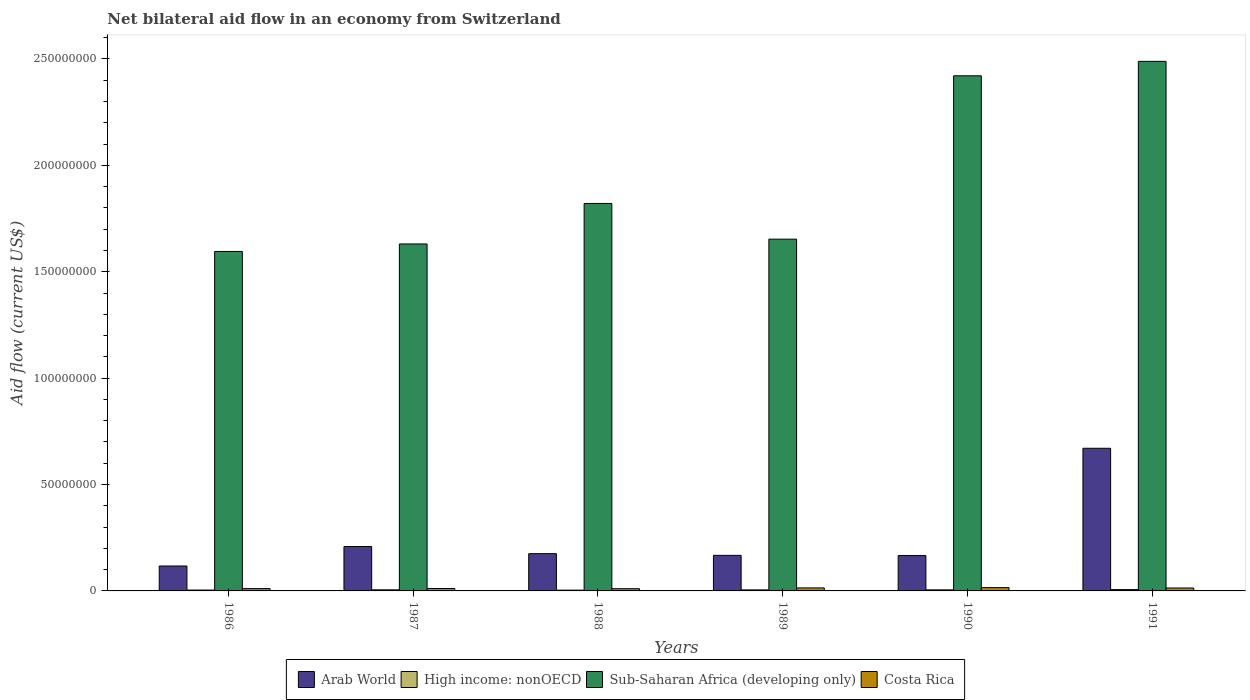How many different coloured bars are there?
Your answer should be compact. 4. How many groups of bars are there?
Make the answer very short. 6. How many bars are there on the 5th tick from the left?
Give a very brief answer. 4. What is the net bilateral aid flow in Arab World in 1988?
Offer a terse response. 1.75e+07. Across all years, what is the maximum net bilateral aid flow in Costa Rica?
Provide a succinct answer. 1.55e+06. In which year was the net bilateral aid flow in High income: nonOECD minimum?
Your response must be concise. 1988. What is the total net bilateral aid flow in Costa Rica in the graph?
Provide a short and direct response. 7.62e+06. What is the difference between the net bilateral aid flow in High income: nonOECD in 1986 and the net bilateral aid flow in Sub-Saharan Africa (developing only) in 1989?
Keep it short and to the point. -1.65e+08. What is the average net bilateral aid flow in High income: nonOECD per year?
Your response must be concise. 4.83e+05. In the year 1986, what is the difference between the net bilateral aid flow in Arab World and net bilateral aid flow in High income: nonOECD?
Ensure brevity in your answer.  1.13e+07. In how many years, is the net bilateral aid flow in Arab World greater than 10000000 US$?
Ensure brevity in your answer.  6. What is the ratio of the net bilateral aid flow in Sub-Saharan Africa (developing only) in 1987 to that in 1989?
Your response must be concise. 0.99. Is the difference between the net bilateral aid flow in Arab World in 1988 and 1989 greater than the difference between the net bilateral aid flow in High income: nonOECD in 1988 and 1989?
Offer a terse response. Yes. What is the difference between the highest and the second highest net bilateral aid flow in Sub-Saharan Africa (developing only)?
Your answer should be compact. 6.79e+06. What is the difference between the highest and the lowest net bilateral aid flow in Arab World?
Keep it short and to the point. 5.53e+07. In how many years, is the net bilateral aid flow in High income: nonOECD greater than the average net bilateral aid flow in High income: nonOECD taken over all years?
Provide a succinct answer. 3. What does the 1st bar from the left in 1988 represents?
Make the answer very short. Arab World. What does the 4th bar from the right in 1986 represents?
Provide a succinct answer. Arab World. Is it the case that in every year, the sum of the net bilateral aid flow in Sub-Saharan Africa (developing only) and net bilateral aid flow in Arab World is greater than the net bilateral aid flow in Costa Rica?
Your answer should be compact. Yes. How many years are there in the graph?
Provide a short and direct response. 6. Where does the legend appear in the graph?
Provide a succinct answer. Bottom center. How many legend labels are there?
Make the answer very short. 4. What is the title of the graph?
Keep it short and to the point. Net bilateral aid flow in an economy from Switzerland. Does "United Arab Emirates" appear as one of the legend labels in the graph?
Your response must be concise. No. What is the label or title of the Y-axis?
Keep it short and to the point. Aid flow (current US$). What is the Aid flow (current US$) in Arab World in 1986?
Give a very brief answer. 1.17e+07. What is the Aid flow (current US$) in Sub-Saharan Africa (developing only) in 1986?
Your answer should be very brief. 1.60e+08. What is the Aid flow (current US$) in Costa Rica in 1986?
Your answer should be compact. 1.10e+06. What is the Aid flow (current US$) in Arab World in 1987?
Offer a very short reply. 2.09e+07. What is the Aid flow (current US$) in High income: nonOECD in 1987?
Provide a succinct answer. 5.20e+05. What is the Aid flow (current US$) of Sub-Saharan Africa (developing only) in 1987?
Make the answer very short. 1.63e+08. What is the Aid flow (current US$) of Costa Rica in 1987?
Your response must be concise. 1.14e+06. What is the Aid flow (current US$) in Arab World in 1988?
Make the answer very short. 1.75e+07. What is the Aid flow (current US$) of High income: nonOECD in 1988?
Your response must be concise. 3.60e+05. What is the Aid flow (current US$) of Sub-Saharan Africa (developing only) in 1988?
Offer a terse response. 1.82e+08. What is the Aid flow (current US$) of Costa Rica in 1988?
Your response must be concise. 1.04e+06. What is the Aid flow (current US$) of Arab World in 1989?
Your answer should be compact. 1.67e+07. What is the Aid flow (current US$) of Sub-Saharan Africa (developing only) in 1989?
Offer a very short reply. 1.65e+08. What is the Aid flow (current US$) of Costa Rica in 1989?
Your answer should be very brief. 1.41e+06. What is the Aid flow (current US$) of Arab World in 1990?
Your answer should be very brief. 1.66e+07. What is the Aid flow (current US$) in Sub-Saharan Africa (developing only) in 1990?
Provide a succinct answer. 2.42e+08. What is the Aid flow (current US$) of Costa Rica in 1990?
Ensure brevity in your answer.  1.55e+06. What is the Aid flow (current US$) of Arab World in 1991?
Keep it short and to the point. 6.70e+07. What is the Aid flow (current US$) in High income: nonOECD in 1991?
Give a very brief answer. 6.30e+05. What is the Aid flow (current US$) in Sub-Saharan Africa (developing only) in 1991?
Give a very brief answer. 2.49e+08. What is the Aid flow (current US$) in Costa Rica in 1991?
Offer a very short reply. 1.38e+06. Across all years, what is the maximum Aid flow (current US$) of Arab World?
Your answer should be very brief. 6.70e+07. Across all years, what is the maximum Aid flow (current US$) of High income: nonOECD?
Your answer should be very brief. 6.30e+05. Across all years, what is the maximum Aid flow (current US$) of Sub-Saharan Africa (developing only)?
Give a very brief answer. 2.49e+08. Across all years, what is the maximum Aid flow (current US$) in Costa Rica?
Ensure brevity in your answer.  1.55e+06. Across all years, what is the minimum Aid flow (current US$) in Arab World?
Provide a short and direct response. 1.17e+07. Across all years, what is the minimum Aid flow (current US$) in High income: nonOECD?
Your answer should be very brief. 3.60e+05. Across all years, what is the minimum Aid flow (current US$) of Sub-Saharan Africa (developing only)?
Give a very brief answer. 1.60e+08. Across all years, what is the minimum Aid flow (current US$) in Costa Rica?
Ensure brevity in your answer.  1.04e+06. What is the total Aid flow (current US$) in Arab World in the graph?
Offer a terse response. 1.50e+08. What is the total Aid flow (current US$) in High income: nonOECD in the graph?
Your answer should be compact. 2.90e+06. What is the total Aid flow (current US$) of Sub-Saharan Africa (developing only) in the graph?
Your response must be concise. 1.16e+09. What is the total Aid flow (current US$) in Costa Rica in the graph?
Your answer should be very brief. 7.62e+06. What is the difference between the Aid flow (current US$) in Arab World in 1986 and that in 1987?
Your answer should be very brief. -9.15e+06. What is the difference between the Aid flow (current US$) of Sub-Saharan Africa (developing only) in 1986 and that in 1987?
Ensure brevity in your answer.  -3.52e+06. What is the difference between the Aid flow (current US$) in Costa Rica in 1986 and that in 1987?
Offer a very short reply. -4.00e+04. What is the difference between the Aid flow (current US$) of Arab World in 1986 and that in 1988?
Your response must be concise. -5.80e+06. What is the difference between the Aid flow (current US$) in Sub-Saharan Africa (developing only) in 1986 and that in 1988?
Your answer should be compact. -2.26e+07. What is the difference between the Aid flow (current US$) in Costa Rica in 1986 and that in 1988?
Keep it short and to the point. 6.00e+04. What is the difference between the Aid flow (current US$) of Arab World in 1986 and that in 1989?
Ensure brevity in your answer.  -4.99e+06. What is the difference between the Aid flow (current US$) of High income: nonOECD in 1986 and that in 1989?
Provide a succinct answer. -7.00e+04. What is the difference between the Aid flow (current US$) in Sub-Saharan Africa (developing only) in 1986 and that in 1989?
Offer a terse response. -5.78e+06. What is the difference between the Aid flow (current US$) of Costa Rica in 1986 and that in 1989?
Give a very brief answer. -3.10e+05. What is the difference between the Aid flow (current US$) in Arab World in 1986 and that in 1990?
Provide a succinct answer. -4.90e+06. What is the difference between the Aid flow (current US$) in Sub-Saharan Africa (developing only) in 1986 and that in 1990?
Keep it short and to the point. -8.26e+07. What is the difference between the Aid flow (current US$) in Costa Rica in 1986 and that in 1990?
Your answer should be very brief. -4.50e+05. What is the difference between the Aid flow (current US$) in Arab World in 1986 and that in 1991?
Ensure brevity in your answer.  -5.53e+07. What is the difference between the Aid flow (current US$) of Sub-Saharan Africa (developing only) in 1986 and that in 1991?
Give a very brief answer. -8.93e+07. What is the difference between the Aid flow (current US$) of Costa Rica in 1986 and that in 1991?
Make the answer very short. -2.80e+05. What is the difference between the Aid flow (current US$) of Arab World in 1987 and that in 1988?
Give a very brief answer. 3.35e+06. What is the difference between the Aid flow (current US$) of Sub-Saharan Africa (developing only) in 1987 and that in 1988?
Offer a very short reply. -1.90e+07. What is the difference between the Aid flow (current US$) in Arab World in 1987 and that in 1989?
Make the answer very short. 4.16e+06. What is the difference between the Aid flow (current US$) of Sub-Saharan Africa (developing only) in 1987 and that in 1989?
Your answer should be compact. -2.26e+06. What is the difference between the Aid flow (current US$) of Arab World in 1987 and that in 1990?
Your answer should be very brief. 4.25e+06. What is the difference between the Aid flow (current US$) in High income: nonOECD in 1987 and that in 1990?
Your answer should be very brief. 2.00e+04. What is the difference between the Aid flow (current US$) in Sub-Saharan Africa (developing only) in 1987 and that in 1990?
Your answer should be very brief. -7.90e+07. What is the difference between the Aid flow (current US$) in Costa Rica in 1987 and that in 1990?
Make the answer very short. -4.10e+05. What is the difference between the Aid flow (current US$) of Arab World in 1987 and that in 1991?
Provide a short and direct response. -4.62e+07. What is the difference between the Aid flow (current US$) in Sub-Saharan Africa (developing only) in 1987 and that in 1991?
Offer a very short reply. -8.58e+07. What is the difference between the Aid flow (current US$) of Arab World in 1988 and that in 1989?
Give a very brief answer. 8.10e+05. What is the difference between the Aid flow (current US$) in Sub-Saharan Africa (developing only) in 1988 and that in 1989?
Your answer should be compact. 1.68e+07. What is the difference between the Aid flow (current US$) in Costa Rica in 1988 and that in 1989?
Offer a terse response. -3.70e+05. What is the difference between the Aid flow (current US$) in Arab World in 1988 and that in 1990?
Your answer should be very brief. 9.00e+05. What is the difference between the Aid flow (current US$) of Sub-Saharan Africa (developing only) in 1988 and that in 1990?
Give a very brief answer. -6.00e+07. What is the difference between the Aid flow (current US$) of Costa Rica in 1988 and that in 1990?
Keep it short and to the point. -5.10e+05. What is the difference between the Aid flow (current US$) in Arab World in 1988 and that in 1991?
Make the answer very short. -4.95e+07. What is the difference between the Aid flow (current US$) in Sub-Saharan Africa (developing only) in 1988 and that in 1991?
Ensure brevity in your answer.  -6.68e+07. What is the difference between the Aid flow (current US$) of High income: nonOECD in 1989 and that in 1990?
Your response must be concise. -2.00e+04. What is the difference between the Aid flow (current US$) in Sub-Saharan Africa (developing only) in 1989 and that in 1990?
Offer a very short reply. -7.68e+07. What is the difference between the Aid flow (current US$) in Costa Rica in 1989 and that in 1990?
Make the answer very short. -1.40e+05. What is the difference between the Aid flow (current US$) in Arab World in 1989 and that in 1991?
Provide a short and direct response. -5.03e+07. What is the difference between the Aid flow (current US$) of Sub-Saharan Africa (developing only) in 1989 and that in 1991?
Your answer should be compact. -8.36e+07. What is the difference between the Aid flow (current US$) of Costa Rica in 1989 and that in 1991?
Give a very brief answer. 3.00e+04. What is the difference between the Aid flow (current US$) in Arab World in 1990 and that in 1991?
Ensure brevity in your answer.  -5.04e+07. What is the difference between the Aid flow (current US$) of Sub-Saharan Africa (developing only) in 1990 and that in 1991?
Give a very brief answer. -6.79e+06. What is the difference between the Aid flow (current US$) of Costa Rica in 1990 and that in 1991?
Your answer should be compact. 1.70e+05. What is the difference between the Aid flow (current US$) in Arab World in 1986 and the Aid flow (current US$) in High income: nonOECD in 1987?
Offer a terse response. 1.12e+07. What is the difference between the Aid flow (current US$) of Arab World in 1986 and the Aid flow (current US$) of Sub-Saharan Africa (developing only) in 1987?
Offer a terse response. -1.51e+08. What is the difference between the Aid flow (current US$) in Arab World in 1986 and the Aid flow (current US$) in Costa Rica in 1987?
Your answer should be very brief. 1.06e+07. What is the difference between the Aid flow (current US$) in High income: nonOECD in 1986 and the Aid flow (current US$) in Sub-Saharan Africa (developing only) in 1987?
Give a very brief answer. -1.63e+08. What is the difference between the Aid flow (current US$) in High income: nonOECD in 1986 and the Aid flow (current US$) in Costa Rica in 1987?
Offer a terse response. -7.30e+05. What is the difference between the Aid flow (current US$) in Sub-Saharan Africa (developing only) in 1986 and the Aid flow (current US$) in Costa Rica in 1987?
Provide a succinct answer. 1.58e+08. What is the difference between the Aid flow (current US$) in Arab World in 1986 and the Aid flow (current US$) in High income: nonOECD in 1988?
Offer a very short reply. 1.14e+07. What is the difference between the Aid flow (current US$) in Arab World in 1986 and the Aid flow (current US$) in Sub-Saharan Africa (developing only) in 1988?
Offer a terse response. -1.70e+08. What is the difference between the Aid flow (current US$) in Arab World in 1986 and the Aid flow (current US$) in Costa Rica in 1988?
Offer a terse response. 1.07e+07. What is the difference between the Aid flow (current US$) in High income: nonOECD in 1986 and the Aid flow (current US$) in Sub-Saharan Africa (developing only) in 1988?
Your answer should be compact. -1.82e+08. What is the difference between the Aid flow (current US$) of High income: nonOECD in 1986 and the Aid flow (current US$) of Costa Rica in 1988?
Keep it short and to the point. -6.30e+05. What is the difference between the Aid flow (current US$) in Sub-Saharan Africa (developing only) in 1986 and the Aid flow (current US$) in Costa Rica in 1988?
Ensure brevity in your answer.  1.59e+08. What is the difference between the Aid flow (current US$) in Arab World in 1986 and the Aid flow (current US$) in High income: nonOECD in 1989?
Ensure brevity in your answer.  1.12e+07. What is the difference between the Aid flow (current US$) in Arab World in 1986 and the Aid flow (current US$) in Sub-Saharan Africa (developing only) in 1989?
Your answer should be compact. -1.54e+08. What is the difference between the Aid flow (current US$) in Arab World in 1986 and the Aid flow (current US$) in Costa Rica in 1989?
Provide a short and direct response. 1.03e+07. What is the difference between the Aid flow (current US$) of High income: nonOECD in 1986 and the Aid flow (current US$) of Sub-Saharan Africa (developing only) in 1989?
Offer a terse response. -1.65e+08. What is the difference between the Aid flow (current US$) of Sub-Saharan Africa (developing only) in 1986 and the Aid flow (current US$) of Costa Rica in 1989?
Your response must be concise. 1.58e+08. What is the difference between the Aid flow (current US$) of Arab World in 1986 and the Aid flow (current US$) of High income: nonOECD in 1990?
Your answer should be compact. 1.12e+07. What is the difference between the Aid flow (current US$) in Arab World in 1986 and the Aid flow (current US$) in Sub-Saharan Africa (developing only) in 1990?
Your response must be concise. -2.30e+08. What is the difference between the Aid flow (current US$) of Arab World in 1986 and the Aid flow (current US$) of Costa Rica in 1990?
Keep it short and to the point. 1.02e+07. What is the difference between the Aid flow (current US$) in High income: nonOECD in 1986 and the Aid flow (current US$) in Sub-Saharan Africa (developing only) in 1990?
Your answer should be compact. -2.42e+08. What is the difference between the Aid flow (current US$) in High income: nonOECD in 1986 and the Aid flow (current US$) in Costa Rica in 1990?
Make the answer very short. -1.14e+06. What is the difference between the Aid flow (current US$) in Sub-Saharan Africa (developing only) in 1986 and the Aid flow (current US$) in Costa Rica in 1990?
Provide a short and direct response. 1.58e+08. What is the difference between the Aid flow (current US$) of Arab World in 1986 and the Aid flow (current US$) of High income: nonOECD in 1991?
Make the answer very short. 1.11e+07. What is the difference between the Aid flow (current US$) of Arab World in 1986 and the Aid flow (current US$) of Sub-Saharan Africa (developing only) in 1991?
Your answer should be compact. -2.37e+08. What is the difference between the Aid flow (current US$) of Arab World in 1986 and the Aid flow (current US$) of Costa Rica in 1991?
Keep it short and to the point. 1.03e+07. What is the difference between the Aid flow (current US$) of High income: nonOECD in 1986 and the Aid flow (current US$) of Sub-Saharan Africa (developing only) in 1991?
Your answer should be compact. -2.48e+08. What is the difference between the Aid flow (current US$) in High income: nonOECD in 1986 and the Aid flow (current US$) in Costa Rica in 1991?
Your answer should be very brief. -9.70e+05. What is the difference between the Aid flow (current US$) of Sub-Saharan Africa (developing only) in 1986 and the Aid flow (current US$) of Costa Rica in 1991?
Offer a terse response. 1.58e+08. What is the difference between the Aid flow (current US$) of Arab World in 1987 and the Aid flow (current US$) of High income: nonOECD in 1988?
Make the answer very short. 2.05e+07. What is the difference between the Aid flow (current US$) of Arab World in 1987 and the Aid flow (current US$) of Sub-Saharan Africa (developing only) in 1988?
Offer a very short reply. -1.61e+08. What is the difference between the Aid flow (current US$) of Arab World in 1987 and the Aid flow (current US$) of Costa Rica in 1988?
Offer a very short reply. 1.98e+07. What is the difference between the Aid flow (current US$) of High income: nonOECD in 1987 and the Aid flow (current US$) of Sub-Saharan Africa (developing only) in 1988?
Your answer should be compact. -1.82e+08. What is the difference between the Aid flow (current US$) of High income: nonOECD in 1987 and the Aid flow (current US$) of Costa Rica in 1988?
Keep it short and to the point. -5.20e+05. What is the difference between the Aid flow (current US$) of Sub-Saharan Africa (developing only) in 1987 and the Aid flow (current US$) of Costa Rica in 1988?
Make the answer very short. 1.62e+08. What is the difference between the Aid flow (current US$) in Arab World in 1987 and the Aid flow (current US$) in High income: nonOECD in 1989?
Provide a succinct answer. 2.04e+07. What is the difference between the Aid flow (current US$) of Arab World in 1987 and the Aid flow (current US$) of Sub-Saharan Africa (developing only) in 1989?
Provide a succinct answer. -1.44e+08. What is the difference between the Aid flow (current US$) of Arab World in 1987 and the Aid flow (current US$) of Costa Rica in 1989?
Offer a very short reply. 1.95e+07. What is the difference between the Aid flow (current US$) in High income: nonOECD in 1987 and the Aid flow (current US$) in Sub-Saharan Africa (developing only) in 1989?
Your answer should be very brief. -1.65e+08. What is the difference between the Aid flow (current US$) of High income: nonOECD in 1987 and the Aid flow (current US$) of Costa Rica in 1989?
Your answer should be very brief. -8.90e+05. What is the difference between the Aid flow (current US$) in Sub-Saharan Africa (developing only) in 1987 and the Aid flow (current US$) in Costa Rica in 1989?
Keep it short and to the point. 1.62e+08. What is the difference between the Aid flow (current US$) in Arab World in 1987 and the Aid flow (current US$) in High income: nonOECD in 1990?
Your answer should be compact. 2.04e+07. What is the difference between the Aid flow (current US$) of Arab World in 1987 and the Aid flow (current US$) of Sub-Saharan Africa (developing only) in 1990?
Your answer should be compact. -2.21e+08. What is the difference between the Aid flow (current US$) in Arab World in 1987 and the Aid flow (current US$) in Costa Rica in 1990?
Make the answer very short. 1.93e+07. What is the difference between the Aid flow (current US$) of High income: nonOECD in 1987 and the Aid flow (current US$) of Sub-Saharan Africa (developing only) in 1990?
Provide a short and direct response. -2.42e+08. What is the difference between the Aid flow (current US$) in High income: nonOECD in 1987 and the Aid flow (current US$) in Costa Rica in 1990?
Give a very brief answer. -1.03e+06. What is the difference between the Aid flow (current US$) of Sub-Saharan Africa (developing only) in 1987 and the Aid flow (current US$) of Costa Rica in 1990?
Ensure brevity in your answer.  1.62e+08. What is the difference between the Aid flow (current US$) in Arab World in 1987 and the Aid flow (current US$) in High income: nonOECD in 1991?
Provide a succinct answer. 2.02e+07. What is the difference between the Aid flow (current US$) in Arab World in 1987 and the Aid flow (current US$) in Sub-Saharan Africa (developing only) in 1991?
Keep it short and to the point. -2.28e+08. What is the difference between the Aid flow (current US$) of Arab World in 1987 and the Aid flow (current US$) of Costa Rica in 1991?
Your answer should be very brief. 1.95e+07. What is the difference between the Aid flow (current US$) in High income: nonOECD in 1987 and the Aid flow (current US$) in Sub-Saharan Africa (developing only) in 1991?
Keep it short and to the point. -2.48e+08. What is the difference between the Aid flow (current US$) of High income: nonOECD in 1987 and the Aid flow (current US$) of Costa Rica in 1991?
Your answer should be very brief. -8.60e+05. What is the difference between the Aid flow (current US$) of Sub-Saharan Africa (developing only) in 1987 and the Aid flow (current US$) of Costa Rica in 1991?
Keep it short and to the point. 1.62e+08. What is the difference between the Aid flow (current US$) of Arab World in 1988 and the Aid flow (current US$) of High income: nonOECD in 1989?
Keep it short and to the point. 1.70e+07. What is the difference between the Aid flow (current US$) of Arab World in 1988 and the Aid flow (current US$) of Sub-Saharan Africa (developing only) in 1989?
Provide a short and direct response. -1.48e+08. What is the difference between the Aid flow (current US$) of Arab World in 1988 and the Aid flow (current US$) of Costa Rica in 1989?
Provide a short and direct response. 1.61e+07. What is the difference between the Aid flow (current US$) of High income: nonOECD in 1988 and the Aid flow (current US$) of Sub-Saharan Africa (developing only) in 1989?
Offer a very short reply. -1.65e+08. What is the difference between the Aid flow (current US$) of High income: nonOECD in 1988 and the Aid flow (current US$) of Costa Rica in 1989?
Ensure brevity in your answer.  -1.05e+06. What is the difference between the Aid flow (current US$) of Sub-Saharan Africa (developing only) in 1988 and the Aid flow (current US$) of Costa Rica in 1989?
Your answer should be compact. 1.81e+08. What is the difference between the Aid flow (current US$) of Arab World in 1988 and the Aid flow (current US$) of High income: nonOECD in 1990?
Your answer should be very brief. 1.70e+07. What is the difference between the Aid flow (current US$) in Arab World in 1988 and the Aid flow (current US$) in Sub-Saharan Africa (developing only) in 1990?
Keep it short and to the point. -2.25e+08. What is the difference between the Aid flow (current US$) of Arab World in 1988 and the Aid flow (current US$) of Costa Rica in 1990?
Ensure brevity in your answer.  1.60e+07. What is the difference between the Aid flow (current US$) of High income: nonOECD in 1988 and the Aid flow (current US$) of Sub-Saharan Africa (developing only) in 1990?
Offer a very short reply. -2.42e+08. What is the difference between the Aid flow (current US$) in High income: nonOECD in 1988 and the Aid flow (current US$) in Costa Rica in 1990?
Keep it short and to the point. -1.19e+06. What is the difference between the Aid flow (current US$) of Sub-Saharan Africa (developing only) in 1988 and the Aid flow (current US$) of Costa Rica in 1990?
Offer a terse response. 1.81e+08. What is the difference between the Aid flow (current US$) of Arab World in 1988 and the Aid flow (current US$) of High income: nonOECD in 1991?
Your response must be concise. 1.69e+07. What is the difference between the Aid flow (current US$) in Arab World in 1988 and the Aid flow (current US$) in Sub-Saharan Africa (developing only) in 1991?
Offer a terse response. -2.31e+08. What is the difference between the Aid flow (current US$) of Arab World in 1988 and the Aid flow (current US$) of Costa Rica in 1991?
Offer a terse response. 1.61e+07. What is the difference between the Aid flow (current US$) in High income: nonOECD in 1988 and the Aid flow (current US$) in Sub-Saharan Africa (developing only) in 1991?
Your answer should be compact. -2.49e+08. What is the difference between the Aid flow (current US$) of High income: nonOECD in 1988 and the Aid flow (current US$) of Costa Rica in 1991?
Make the answer very short. -1.02e+06. What is the difference between the Aid flow (current US$) of Sub-Saharan Africa (developing only) in 1988 and the Aid flow (current US$) of Costa Rica in 1991?
Your response must be concise. 1.81e+08. What is the difference between the Aid flow (current US$) of Arab World in 1989 and the Aid flow (current US$) of High income: nonOECD in 1990?
Your answer should be compact. 1.62e+07. What is the difference between the Aid flow (current US$) of Arab World in 1989 and the Aid flow (current US$) of Sub-Saharan Africa (developing only) in 1990?
Offer a terse response. -2.25e+08. What is the difference between the Aid flow (current US$) in Arab World in 1989 and the Aid flow (current US$) in Costa Rica in 1990?
Provide a short and direct response. 1.52e+07. What is the difference between the Aid flow (current US$) in High income: nonOECD in 1989 and the Aid flow (current US$) in Sub-Saharan Africa (developing only) in 1990?
Your answer should be compact. -2.42e+08. What is the difference between the Aid flow (current US$) in High income: nonOECD in 1989 and the Aid flow (current US$) in Costa Rica in 1990?
Offer a terse response. -1.07e+06. What is the difference between the Aid flow (current US$) in Sub-Saharan Africa (developing only) in 1989 and the Aid flow (current US$) in Costa Rica in 1990?
Offer a very short reply. 1.64e+08. What is the difference between the Aid flow (current US$) of Arab World in 1989 and the Aid flow (current US$) of High income: nonOECD in 1991?
Your response must be concise. 1.61e+07. What is the difference between the Aid flow (current US$) of Arab World in 1989 and the Aid flow (current US$) of Sub-Saharan Africa (developing only) in 1991?
Give a very brief answer. -2.32e+08. What is the difference between the Aid flow (current US$) in Arab World in 1989 and the Aid flow (current US$) in Costa Rica in 1991?
Offer a very short reply. 1.53e+07. What is the difference between the Aid flow (current US$) in High income: nonOECD in 1989 and the Aid flow (current US$) in Sub-Saharan Africa (developing only) in 1991?
Your answer should be compact. -2.48e+08. What is the difference between the Aid flow (current US$) of High income: nonOECD in 1989 and the Aid flow (current US$) of Costa Rica in 1991?
Your answer should be compact. -9.00e+05. What is the difference between the Aid flow (current US$) of Sub-Saharan Africa (developing only) in 1989 and the Aid flow (current US$) of Costa Rica in 1991?
Your answer should be compact. 1.64e+08. What is the difference between the Aid flow (current US$) in Arab World in 1990 and the Aid flow (current US$) in High income: nonOECD in 1991?
Keep it short and to the point. 1.60e+07. What is the difference between the Aid flow (current US$) in Arab World in 1990 and the Aid flow (current US$) in Sub-Saharan Africa (developing only) in 1991?
Provide a succinct answer. -2.32e+08. What is the difference between the Aid flow (current US$) of Arab World in 1990 and the Aid flow (current US$) of Costa Rica in 1991?
Give a very brief answer. 1.52e+07. What is the difference between the Aid flow (current US$) of High income: nonOECD in 1990 and the Aid flow (current US$) of Sub-Saharan Africa (developing only) in 1991?
Offer a very short reply. -2.48e+08. What is the difference between the Aid flow (current US$) in High income: nonOECD in 1990 and the Aid flow (current US$) in Costa Rica in 1991?
Ensure brevity in your answer.  -8.80e+05. What is the difference between the Aid flow (current US$) in Sub-Saharan Africa (developing only) in 1990 and the Aid flow (current US$) in Costa Rica in 1991?
Provide a succinct answer. 2.41e+08. What is the average Aid flow (current US$) of Arab World per year?
Ensure brevity in your answer.  2.51e+07. What is the average Aid flow (current US$) in High income: nonOECD per year?
Provide a succinct answer. 4.83e+05. What is the average Aid flow (current US$) of Sub-Saharan Africa (developing only) per year?
Ensure brevity in your answer.  1.94e+08. What is the average Aid flow (current US$) of Costa Rica per year?
Keep it short and to the point. 1.27e+06. In the year 1986, what is the difference between the Aid flow (current US$) of Arab World and Aid flow (current US$) of High income: nonOECD?
Offer a very short reply. 1.13e+07. In the year 1986, what is the difference between the Aid flow (current US$) in Arab World and Aid flow (current US$) in Sub-Saharan Africa (developing only)?
Your answer should be compact. -1.48e+08. In the year 1986, what is the difference between the Aid flow (current US$) of Arab World and Aid flow (current US$) of Costa Rica?
Offer a terse response. 1.06e+07. In the year 1986, what is the difference between the Aid flow (current US$) in High income: nonOECD and Aid flow (current US$) in Sub-Saharan Africa (developing only)?
Offer a very short reply. -1.59e+08. In the year 1986, what is the difference between the Aid flow (current US$) in High income: nonOECD and Aid flow (current US$) in Costa Rica?
Give a very brief answer. -6.90e+05. In the year 1986, what is the difference between the Aid flow (current US$) in Sub-Saharan Africa (developing only) and Aid flow (current US$) in Costa Rica?
Offer a terse response. 1.58e+08. In the year 1987, what is the difference between the Aid flow (current US$) in Arab World and Aid flow (current US$) in High income: nonOECD?
Your answer should be very brief. 2.04e+07. In the year 1987, what is the difference between the Aid flow (current US$) in Arab World and Aid flow (current US$) in Sub-Saharan Africa (developing only)?
Offer a very short reply. -1.42e+08. In the year 1987, what is the difference between the Aid flow (current US$) of Arab World and Aid flow (current US$) of Costa Rica?
Offer a very short reply. 1.97e+07. In the year 1987, what is the difference between the Aid flow (current US$) in High income: nonOECD and Aid flow (current US$) in Sub-Saharan Africa (developing only)?
Keep it short and to the point. -1.63e+08. In the year 1987, what is the difference between the Aid flow (current US$) of High income: nonOECD and Aid flow (current US$) of Costa Rica?
Your answer should be compact. -6.20e+05. In the year 1987, what is the difference between the Aid flow (current US$) in Sub-Saharan Africa (developing only) and Aid flow (current US$) in Costa Rica?
Make the answer very short. 1.62e+08. In the year 1988, what is the difference between the Aid flow (current US$) in Arab World and Aid flow (current US$) in High income: nonOECD?
Make the answer very short. 1.72e+07. In the year 1988, what is the difference between the Aid flow (current US$) of Arab World and Aid flow (current US$) of Sub-Saharan Africa (developing only)?
Provide a succinct answer. -1.65e+08. In the year 1988, what is the difference between the Aid flow (current US$) of Arab World and Aid flow (current US$) of Costa Rica?
Your answer should be very brief. 1.65e+07. In the year 1988, what is the difference between the Aid flow (current US$) in High income: nonOECD and Aid flow (current US$) in Sub-Saharan Africa (developing only)?
Make the answer very short. -1.82e+08. In the year 1988, what is the difference between the Aid flow (current US$) in High income: nonOECD and Aid flow (current US$) in Costa Rica?
Keep it short and to the point. -6.80e+05. In the year 1988, what is the difference between the Aid flow (current US$) in Sub-Saharan Africa (developing only) and Aid flow (current US$) in Costa Rica?
Give a very brief answer. 1.81e+08. In the year 1989, what is the difference between the Aid flow (current US$) of Arab World and Aid flow (current US$) of High income: nonOECD?
Your answer should be very brief. 1.62e+07. In the year 1989, what is the difference between the Aid flow (current US$) in Arab World and Aid flow (current US$) in Sub-Saharan Africa (developing only)?
Ensure brevity in your answer.  -1.49e+08. In the year 1989, what is the difference between the Aid flow (current US$) in Arab World and Aid flow (current US$) in Costa Rica?
Your answer should be compact. 1.53e+07. In the year 1989, what is the difference between the Aid flow (current US$) in High income: nonOECD and Aid flow (current US$) in Sub-Saharan Africa (developing only)?
Give a very brief answer. -1.65e+08. In the year 1989, what is the difference between the Aid flow (current US$) in High income: nonOECD and Aid flow (current US$) in Costa Rica?
Provide a short and direct response. -9.30e+05. In the year 1989, what is the difference between the Aid flow (current US$) of Sub-Saharan Africa (developing only) and Aid flow (current US$) of Costa Rica?
Your response must be concise. 1.64e+08. In the year 1990, what is the difference between the Aid flow (current US$) in Arab World and Aid flow (current US$) in High income: nonOECD?
Your answer should be compact. 1.61e+07. In the year 1990, what is the difference between the Aid flow (current US$) of Arab World and Aid flow (current US$) of Sub-Saharan Africa (developing only)?
Offer a terse response. -2.25e+08. In the year 1990, what is the difference between the Aid flow (current US$) of Arab World and Aid flow (current US$) of Costa Rica?
Provide a short and direct response. 1.51e+07. In the year 1990, what is the difference between the Aid flow (current US$) in High income: nonOECD and Aid flow (current US$) in Sub-Saharan Africa (developing only)?
Provide a short and direct response. -2.42e+08. In the year 1990, what is the difference between the Aid flow (current US$) of High income: nonOECD and Aid flow (current US$) of Costa Rica?
Give a very brief answer. -1.05e+06. In the year 1990, what is the difference between the Aid flow (current US$) of Sub-Saharan Africa (developing only) and Aid flow (current US$) of Costa Rica?
Your answer should be very brief. 2.41e+08. In the year 1991, what is the difference between the Aid flow (current US$) of Arab World and Aid flow (current US$) of High income: nonOECD?
Keep it short and to the point. 6.64e+07. In the year 1991, what is the difference between the Aid flow (current US$) in Arab World and Aid flow (current US$) in Sub-Saharan Africa (developing only)?
Give a very brief answer. -1.82e+08. In the year 1991, what is the difference between the Aid flow (current US$) of Arab World and Aid flow (current US$) of Costa Rica?
Provide a short and direct response. 6.57e+07. In the year 1991, what is the difference between the Aid flow (current US$) in High income: nonOECD and Aid flow (current US$) in Sub-Saharan Africa (developing only)?
Provide a short and direct response. -2.48e+08. In the year 1991, what is the difference between the Aid flow (current US$) of High income: nonOECD and Aid flow (current US$) of Costa Rica?
Your answer should be compact. -7.50e+05. In the year 1991, what is the difference between the Aid flow (current US$) of Sub-Saharan Africa (developing only) and Aid flow (current US$) of Costa Rica?
Your response must be concise. 2.48e+08. What is the ratio of the Aid flow (current US$) of Arab World in 1986 to that in 1987?
Provide a short and direct response. 0.56. What is the ratio of the Aid flow (current US$) in High income: nonOECD in 1986 to that in 1987?
Your answer should be compact. 0.79. What is the ratio of the Aid flow (current US$) in Sub-Saharan Africa (developing only) in 1986 to that in 1987?
Your response must be concise. 0.98. What is the ratio of the Aid flow (current US$) in Costa Rica in 1986 to that in 1987?
Make the answer very short. 0.96. What is the ratio of the Aid flow (current US$) of Arab World in 1986 to that in 1988?
Make the answer very short. 0.67. What is the ratio of the Aid flow (current US$) in High income: nonOECD in 1986 to that in 1988?
Your answer should be compact. 1.14. What is the ratio of the Aid flow (current US$) in Sub-Saharan Africa (developing only) in 1986 to that in 1988?
Your answer should be very brief. 0.88. What is the ratio of the Aid flow (current US$) in Costa Rica in 1986 to that in 1988?
Give a very brief answer. 1.06. What is the ratio of the Aid flow (current US$) in Arab World in 1986 to that in 1989?
Offer a very short reply. 0.7. What is the ratio of the Aid flow (current US$) of High income: nonOECD in 1986 to that in 1989?
Ensure brevity in your answer.  0.85. What is the ratio of the Aid flow (current US$) of Sub-Saharan Africa (developing only) in 1986 to that in 1989?
Your response must be concise. 0.96. What is the ratio of the Aid flow (current US$) in Costa Rica in 1986 to that in 1989?
Offer a terse response. 0.78. What is the ratio of the Aid flow (current US$) of Arab World in 1986 to that in 1990?
Offer a very short reply. 0.71. What is the ratio of the Aid flow (current US$) in High income: nonOECD in 1986 to that in 1990?
Your response must be concise. 0.82. What is the ratio of the Aid flow (current US$) of Sub-Saharan Africa (developing only) in 1986 to that in 1990?
Offer a terse response. 0.66. What is the ratio of the Aid flow (current US$) of Costa Rica in 1986 to that in 1990?
Give a very brief answer. 0.71. What is the ratio of the Aid flow (current US$) of Arab World in 1986 to that in 1991?
Give a very brief answer. 0.17. What is the ratio of the Aid flow (current US$) in High income: nonOECD in 1986 to that in 1991?
Provide a short and direct response. 0.65. What is the ratio of the Aid flow (current US$) of Sub-Saharan Africa (developing only) in 1986 to that in 1991?
Your response must be concise. 0.64. What is the ratio of the Aid flow (current US$) of Costa Rica in 1986 to that in 1991?
Your response must be concise. 0.8. What is the ratio of the Aid flow (current US$) of Arab World in 1987 to that in 1988?
Make the answer very short. 1.19. What is the ratio of the Aid flow (current US$) of High income: nonOECD in 1987 to that in 1988?
Your response must be concise. 1.44. What is the ratio of the Aid flow (current US$) in Sub-Saharan Africa (developing only) in 1987 to that in 1988?
Provide a succinct answer. 0.9. What is the ratio of the Aid flow (current US$) in Costa Rica in 1987 to that in 1988?
Your answer should be very brief. 1.1. What is the ratio of the Aid flow (current US$) of Arab World in 1987 to that in 1989?
Provide a succinct answer. 1.25. What is the ratio of the Aid flow (current US$) in Sub-Saharan Africa (developing only) in 1987 to that in 1989?
Your answer should be very brief. 0.99. What is the ratio of the Aid flow (current US$) in Costa Rica in 1987 to that in 1989?
Your answer should be very brief. 0.81. What is the ratio of the Aid flow (current US$) of Arab World in 1987 to that in 1990?
Ensure brevity in your answer.  1.26. What is the ratio of the Aid flow (current US$) in High income: nonOECD in 1987 to that in 1990?
Your answer should be very brief. 1.04. What is the ratio of the Aid flow (current US$) in Sub-Saharan Africa (developing only) in 1987 to that in 1990?
Your answer should be compact. 0.67. What is the ratio of the Aid flow (current US$) in Costa Rica in 1987 to that in 1990?
Offer a very short reply. 0.74. What is the ratio of the Aid flow (current US$) in Arab World in 1987 to that in 1991?
Make the answer very short. 0.31. What is the ratio of the Aid flow (current US$) in High income: nonOECD in 1987 to that in 1991?
Your answer should be compact. 0.83. What is the ratio of the Aid flow (current US$) in Sub-Saharan Africa (developing only) in 1987 to that in 1991?
Provide a succinct answer. 0.66. What is the ratio of the Aid flow (current US$) of Costa Rica in 1987 to that in 1991?
Your response must be concise. 0.83. What is the ratio of the Aid flow (current US$) in Arab World in 1988 to that in 1989?
Your response must be concise. 1.05. What is the ratio of the Aid flow (current US$) of Sub-Saharan Africa (developing only) in 1988 to that in 1989?
Your response must be concise. 1.1. What is the ratio of the Aid flow (current US$) in Costa Rica in 1988 to that in 1989?
Offer a very short reply. 0.74. What is the ratio of the Aid flow (current US$) in Arab World in 1988 to that in 1990?
Your answer should be very brief. 1.05. What is the ratio of the Aid flow (current US$) in High income: nonOECD in 1988 to that in 1990?
Offer a very short reply. 0.72. What is the ratio of the Aid flow (current US$) of Sub-Saharan Africa (developing only) in 1988 to that in 1990?
Your response must be concise. 0.75. What is the ratio of the Aid flow (current US$) of Costa Rica in 1988 to that in 1990?
Give a very brief answer. 0.67. What is the ratio of the Aid flow (current US$) in Arab World in 1988 to that in 1991?
Your answer should be very brief. 0.26. What is the ratio of the Aid flow (current US$) in Sub-Saharan Africa (developing only) in 1988 to that in 1991?
Offer a very short reply. 0.73. What is the ratio of the Aid flow (current US$) in Costa Rica in 1988 to that in 1991?
Provide a succinct answer. 0.75. What is the ratio of the Aid flow (current US$) in Arab World in 1989 to that in 1990?
Your response must be concise. 1.01. What is the ratio of the Aid flow (current US$) of Sub-Saharan Africa (developing only) in 1989 to that in 1990?
Provide a short and direct response. 0.68. What is the ratio of the Aid flow (current US$) of Costa Rica in 1989 to that in 1990?
Make the answer very short. 0.91. What is the ratio of the Aid flow (current US$) in Arab World in 1989 to that in 1991?
Provide a short and direct response. 0.25. What is the ratio of the Aid flow (current US$) in High income: nonOECD in 1989 to that in 1991?
Make the answer very short. 0.76. What is the ratio of the Aid flow (current US$) of Sub-Saharan Africa (developing only) in 1989 to that in 1991?
Your answer should be very brief. 0.66. What is the ratio of the Aid flow (current US$) of Costa Rica in 1989 to that in 1991?
Make the answer very short. 1.02. What is the ratio of the Aid flow (current US$) of Arab World in 1990 to that in 1991?
Ensure brevity in your answer.  0.25. What is the ratio of the Aid flow (current US$) in High income: nonOECD in 1990 to that in 1991?
Give a very brief answer. 0.79. What is the ratio of the Aid flow (current US$) of Sub-Saharan Africa (developing only) in 1990 to that in 1991?
Provide a succinct answer. 0.97. What is the ratio of the Aid flow (current US$) in Costa Rica in 1990 to that in 1991?
Your answer should be very brief. 1.12. What is the difference between the highest and the second highest Aid flow (current US$) of Arab World?
Your response must be concise. 4.62e+07. What is the difference between the highest and the second highest Aid flow (current US$) of High income: nonOECD?
Make the answer very short. 1.10e+05. What is the difference between the highest and the second highest Aid flow (current US$) of Sub-Saharan Africa (developing only)?
Offer a very short reply. 6.79e+06. What is the difference between the highest and the lowest Aid flow (current US$) of Arab World?
Ensure brevity in your answer.  5.53e+07. What is the difference between the highest and the lowest Aid flow (current US$) in High income: nonOECD?
Make the answer very short. 2.70e+05. What is the difference between the highest and the lowest Aid flow (current US$) of Sub-Saharan Africa (developing only)?
Your answer should be compact. 8.93e+07. What is the difference between the highest and the lowest Aid flow (current US$) in Costa Rica?
Offer a terse response. 5.10e+05. 